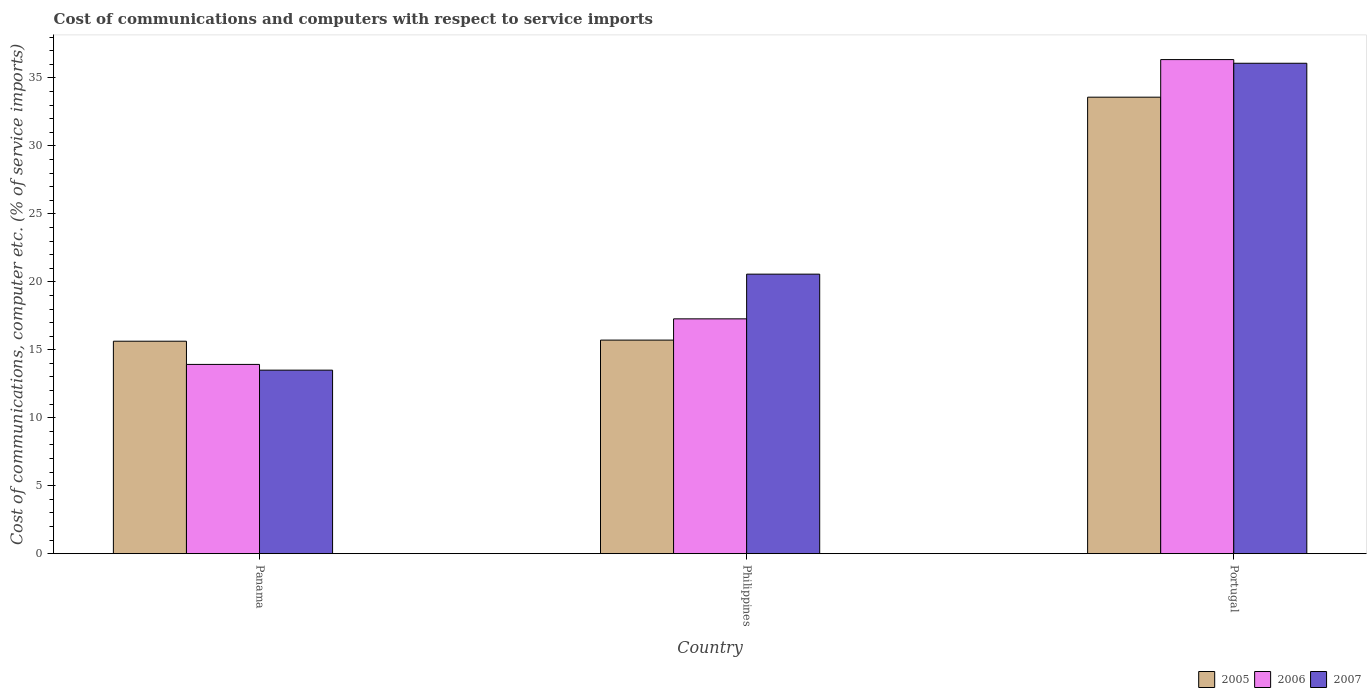Are the number of bars on each tick of the X-axis equal?
Your response must be concise. Yes. How many bars are there on the 1st tick from the right?
Offer a terse response. 3. What is the label of the 2nd group of bars from the left?
Offer a terse response. Philippines. In how many cases, is the number of bars for a given country not equal to the number of legend labels?
Ensure brevity in your answer.  0. What is the cost of communications and computers in 2007 in Panama?
Give a very brief answer. 13.5. Across all countries, what is the maximum cost of communications and computers in 2005?
Offer a terse response. 33.59. Across all countries, what is the minimum cost of communications and computers in 2007?
Ensure brevity in your answer.  13.5. In which country was the cost of communications and computers in 2006 minimum?
Provide a succinct answer. Panama. What is the total cost of communications and computers in 2005 in the graph?
Provide a succinct answer. 64.93. What is the difference between the cost of communications and computers in 2007 in Philippines and that in Portugal?
Provide a succinct answer. -15.52. What is the difference between the cost of communications and computers in 2005 in Panama and the cost of communications and computers in 2007 in Portugal?
Provide a short and direct response. -20.45. What is the average cost of communications and computers in 2007 per country?
Give a very brief answer. 23.38. What is the difference between the cost of communications and computers of/in 2005 and cost of communications and computers of/in 2007 in Portugal?
Offer a very short reply. -2.5. In how many countries, is the cost of communications and computers in 2007 greater than 3 %?
Give a very brief answer. 3. What is the ratio of the cost of communications and computers in 2006 in Philippines to that in Portugal?
Offer a terse response. 0.48. Is the cost of communications and computers in 2007 in Panama less than that in Portugal?
Offer a very short reply. Yes. What is the difference between the highest and the second highest cost of communications and computers in 2005?
Offer a terse response. 17.96. What is the difference between the highest and the lowest cost of communications and computers in 2006?
Offer a very short reply. 22.43. What does the 1st bar from the right in Philippines represents?
Your answer should be very brief. 2007. How many bars are there?
Provide a succinct answer. 9. How many countries are there in the graph?
Provide a succinct answer. 3. Does the graph contain any zero values?
Offer a terse response. No. Where does the legend appear in the graph?
Your response must be concise. Bottom right. How many legend labels are there?
Provide a succinct answer. 3. What is the title of the graph?
Provide a short and direct response. Cost of communications and computers with respect to service imports. Does "1987" appear as one of the legend labels in the graph?
Your answer should be compact. No. What is the label or title of the Y-axis?
Give a very brief answer. Cost of communications, computer etc. (% of service imports). What is the Cost of communications, computer etc. (% of service imports) of 2005 in Panama?
Ensure brevity in your answer.  15.63. What is the Cost of communications, computer etc. (% of service imports) of 2006 in Panama?
Offer a terse response. 13.92. What is the Cost of communications, computer etc. (% of service imports) of 2007 in Panama?
Make the answer very short. 13.5. What is the Cost of communications, computer etc. (% of service imports) of 2005 in Philippines?
Your answer should be very brief. 15.71. What is the Cost of communications, computer etc. (% of service imports) in 2006 in Philippines?
Give a very brief answer. 17.28. What is the Cost of communications, computer etc. (% of service imports) of 2007 in Philippines?
Give a very brief answer. 20.57. What is the Cost of communications, computer etc. (% of service imports) in 2005 in Portugal?
Offer a terse response. 33.59. What is the Cost of communications, computer etc. (% of service imports) of 2006 in Portugal?
Provide a short and direct response. 36.35. What is the Cost of communications, computer etc. (% of service imports) of 2007 in Portugal?
Your response must be concise. 36.08. Across all countries, what is the maximum Cost of communications, computer etc. (% of service imports) of 2005?
Provide a succinct answer. 33.59. Across all countries, what is the maximum Cost of communications, computer etc. (% of service imports) of 2006?
Your response must be concise. 36.35. Across all countries, what is the maximum Cost of communications, computer etc. (% of service imports) of 2007?
Provide a succinct answer. 36.08. Across all countries, what is the minimum Cost of communications, computer etc. (% of service imports) of 2005?
Make the answer very short. 15.63. Across all countries, what is the minimum Cost of communications, computer etc. (% of service imports) in 2006?
Keep it short and to the point. 13.92. Across all countries, what is the minimum Cost of communications, computer etc. (% of service imports) of 2007?
Offer a terse response. 13.5. What is the total Cost of communications, computer etc. (% of service imports) in 2005 in the graph?
Ensure brevity in your answer.  64.93. What is the total Cost of communications, computer etc. (% of service imports) in 2006 in the graph?
Your answer should be compact. 67.56. What is the total Cost of communications, computer etc. (% of service imports) of 2007 in the graph?
Your answer should be very brief. 70.15. What is the difference between the Cost of communications, computer etc. (% of service imports) in 2005 in Panama and that in Philippines?
Provide a short and direct response. -0.08. What is the difference between the Cost of communications, computer etc. (% of service imports) in 2006 in Panama and that in Philippines?
Provide a succinct answer. -3.35. What is the difference between the Cost of communications, computer etc. (% of service imports) in 2007 in Panama and that in Philippines?
Give a very brief answer. -7.06. What is the difference between the Cost of communications, computer etc. (% of service imports) in 2005 in Panama and that in Portugal?
Make the answer very short. -17.96. What is the difference between the Cost of communications, computer etc. (% of service imports) of 2006 in Panama and that in Portugal?
Give a very brief answer. -22.43. What is the difference between the Cost of communications, computer etc. (% of service imports) of 2007 in Panama and that in Portugal?
Keep it short and to the point. -22.58. What is the difference between the Cost of communications, computer etc. (% of service imports) in 2005 in Philippines and that in Portugal?
Provide a succinct answer. -17.87. What is the difference between the Cost of communications, computer etc. (% of service imports) of 2006 in Philippines and that in Portugal?
Your answer should be very brief. -19.08. What is the difference between the Cost of communications, computer etc. (% of service imports) in 2007 in Philippines and that in Portugal?
Offer a terse response. -15.52. What is the difference between the Cost of communications, computer etc. (% of service imports) of 2005 in Panama and the Cost of communications, computer etc. (% of service imports) of 2006 in Philippines?
Provide a succinct answer. -1.65. What is the difference between the Cost of communications, computer etc. (% of service imports) of 2005 in Panama and the Cost of communications, computer etc. (% of service imports) of 2007 in Philippines?
Provide a short and direct response. -4.93. What is the difference between the Cost of communications, computer etc. (% of service imports) of 2006 in Panama and the Cost of communications, computer etc. (% of service imports) of 2007 in Philippines?
Make the answer very short. -6.64. What is the difference between the Cost of communications, computer etc. (% of service imports) of 2005 in Panama and the Cost of communications, computer etc. (% of service imports) of 2006 in Portugal?
Your answer should be very brief. -20.72. What is the difference between the Cost of communications, computer etc. (% of service imports) in 2005 in Panama and the Cost of communications, computer etc. (% of service imports) in 2007 in Portugal?
Your answer should be very brief. -20.45. What is the difference between the Cost of communications, computer etc. (% of service imports) in 2006 in Panama and the Cost of communications, computer etc. (% of service imports) in 2007 in Portugal?
Give a very brief answer. -22.16. What is the difference between the Cost of communications, computer etc. (% of service imports) of 2005 in Philippines and the Cost of communications, computer etc. (% of service imports) of 2006 in Portugal?
Your response must be concise. -20.64. What is the difference between the Cost of communications, computer etc. (% of service imports) in 2005 in Philippines and the Cost of communications, computer etc. (% of service imports) in 2007 in Portugal?
Give a very brief answer. -20.37. What is the difference between the Cost of communications, computer etc. (% of service imports) in 2006 in Philippines and the Cost of communications, computer etc. (% of service imports) in 2007 in Portugal?
Offer a very short reply. -18.81. What is the average Cost of communications, computer etc. (% of service imports) in 2005 per country?
Give a very brief answer. 21.64. What is the average Cost of communications, computer etc. (% of service imports) of 2006 per country?
Provide a succinct answer. 22.52. What is the average Cost of communications, computer etc. (% of service imports) in 2007 per country?
Give a very brief answer. 23.38. What is the difference between the Cost of communications, computer etc. (% of service imports) in 2005 and Cost of communications, computer etc. (% of service imports) in 2006 in Panama?
Give a very brief answer. 1.71. What is the difference between the Cost of communications, computer etc. (% of service imports) in 2005 and Cost of communications, computer etc. (% of service imports) in 2007 in Panama?
Keep it short and to the point. 2.13. What is the difference between the Cost of communications, computer etc. (% of service imports) of 2006 and Cost of communications, computer etc. (% of service imports) of 2007 in Panama?
Your response must be concise. 0.42. What is the difference between the Cost of communications, computer etc. (% of service imports) in 2005 and Cost of communications, computer etc. (% of service imports) in 2006 in Philippines?
Provide a short and direct response. -1.56. What is the difference between the Cost of communications, computer etc. (% of service imports) in 2005 and Cost of communications, computer etc. (% of service imports) in 2007 in Philippines?
Give a very brief answer. -4.85. What is the difference between the Cost of communications, computer etc. (% of service imports) in 2006 and Cost of communications, computer etc. (% of service imports) in 2007 in Philippines?
Ensure brevity in your answer.  -3.29. What is the difference between the Cost of communications, computer etc. (% of service imports) of 2005 and Cost of communications, computer etc. (% of service imports) of 2006 in Portugal?
Your answer should be compact. -2.77. What is the difference between the Cost of communications, computer etc. (% of service imports) of 2005 and Cost of communications, computer etc. (% of service imports) of 2007 in Portugal?
Your answer should be very brief. -2.5. What is the difference between the Cost of communications, computer etc. (% of service imports) in 2006 and Cost of communications, computer etc. (% of service imports) in 2007 in Portugal?
Give a very brief answer. 0.27. What is the ratio of the Cost of communications, computer etc. (% of service imports) in 2006 in Panama to that in Philippines?
Your answer should be compact. 0.81. What is the ratio of the Cost of communications, computer etc. (% of service imports) in 2007 in Panama to that in Philippines?
Your answer should be very brief. 0.66. What is the ratio of the Cost of communications, computer etc. (% of service imports) in 2005 in Panama to that in Portugal?
Ensure brevity in your answer.  0.47. What is the ratio of the Cost of communications, computer etc. (% of service imports) in 2006 in Panama to that in Portugal?
Your response must be concise. 0.38. What is the ratio of the Cost of communications, computer etc. (% of service imports) in 2007 in Panama to that in Portugal?
Make the answer very short. 0.37. What is the ratio of the Cost of communications, computer etc. (% of service imports) in 2005 in Philippines to that in Portugal?
Your response must be concise. 0.47. What is the ratio of the Cost of communications, computer etc. (% of service imports) in 2006 in Philippines to that in Portugal?
Your response must be concise. 0.48. What is the ratio of the Cost of communications, computer etc. (% of service imports) of 2007 in Philippines to that in Portugal?
Ensure brevity in your answer.  0.57. What is the difference between the highest and the second highest Cost of communications, computer etc. (% of service imports) of 2005?
Make the answer very short. 17.87. What is the difference between the highest and the second highest Cost of communications, computer etc. (% of service imports) of 2006?
Your response must be concise. 19.08. What is the difference between the highest and the second highest Cost of communications, computer etc. (% of service imports) in 2007?
Provide a succinct answer. 15.52. What is the difference between the highest and the lowest Cost of communications, computer etc. (% of service imports) in 2005?
Provide a short and direct response. 17.96. What is the difference between the highest and the lowest Cost of communications, computer etc. (% of service imports) of 2006?
Ensure brevity in your answer.  22.43. What is the difference between the highest and the lowest Cost of communications, computer etc. (% of service imports) of 2007?
Your response must be concise. 22.58. 